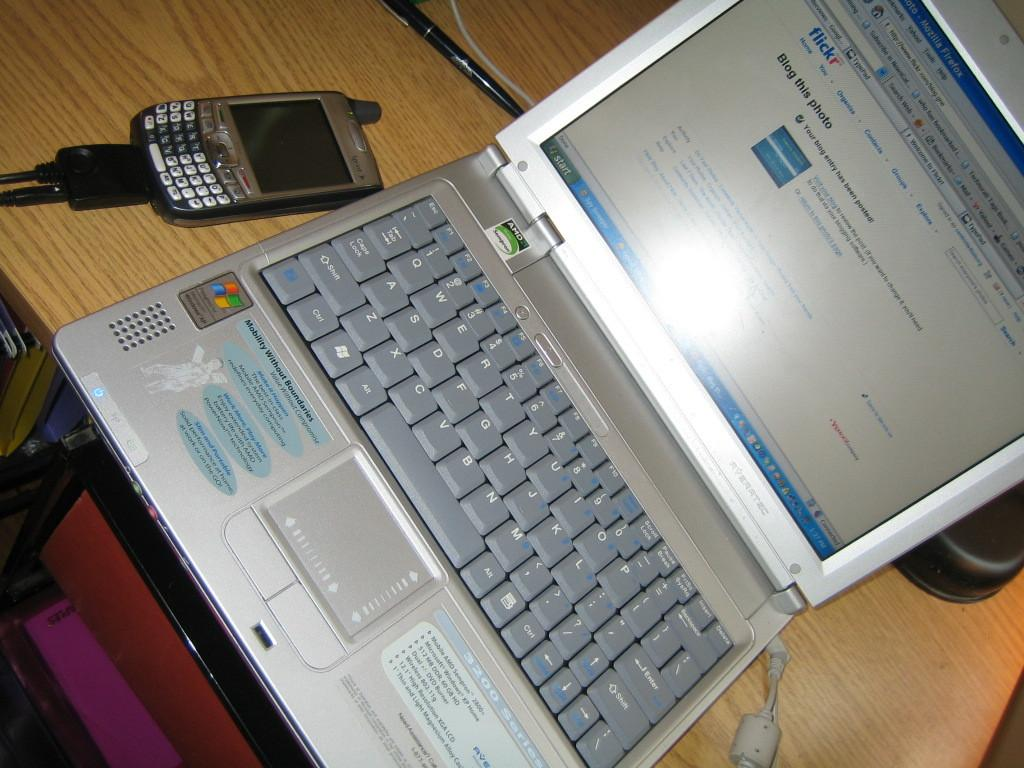<image>
Offer a succinct explanation of the picture presented. a silver laptop running on windows XP processor 